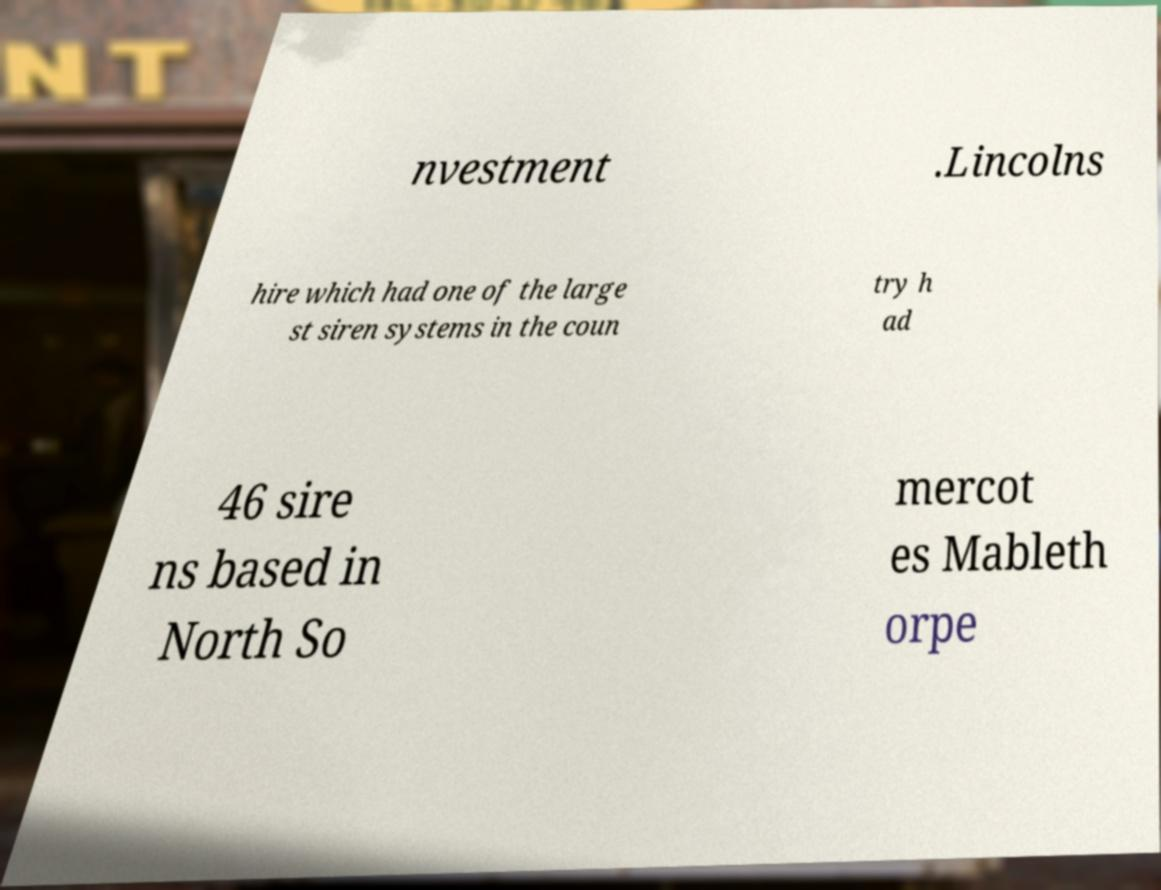Please read and relay the text visible in this image. What does it say? nvestment .Lincolns hire which had one of the large st siren systems in the coun try h ad 46 sire ns based in North So mercot es Mableth orpe 